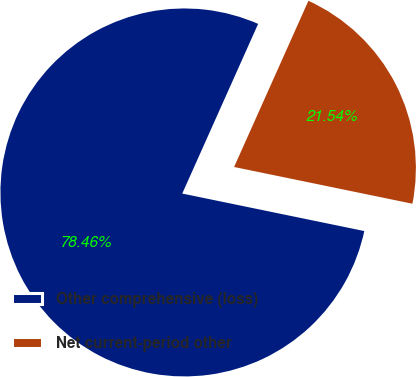Convert chart to OTSL. <chart><loc_0><loc_0><loc_500><loc_500><pie_chart><fcel>Other comprehensive (loss)<fcel>Net current-period other<nl><fcel>78.46%<fcel>21.54%<nl></chart> 